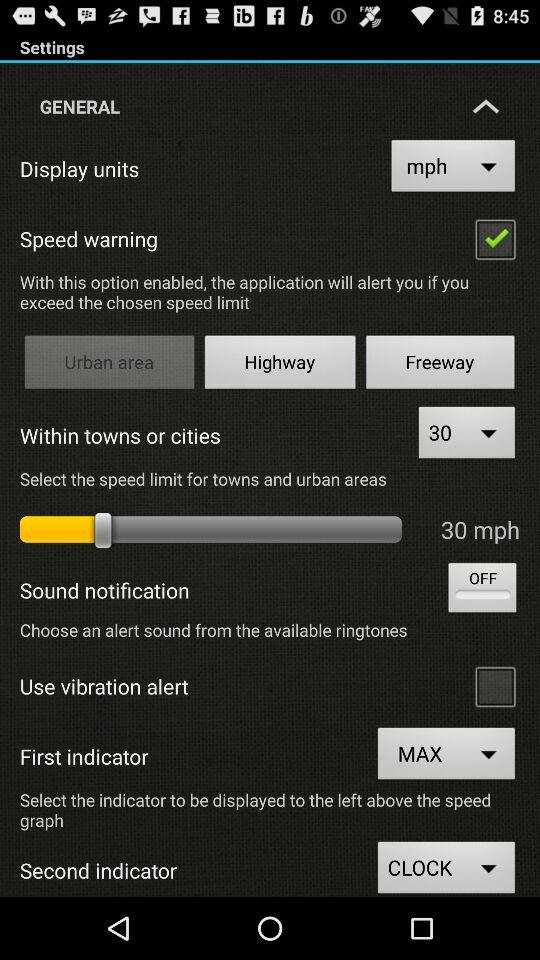How many speed limits are available to select?
Answer the question using a single word or phrase. 3 